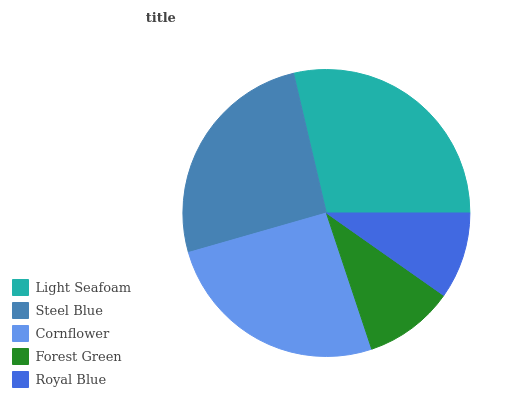Is Royal Blue the minimum?
Answer yes or no. Yes. Is Light Seafoam the maximum?
Answer yes or no. Yes. Is Steel Blue the minimum?
Answer yes or no. No. Is Steel Blue the maximum?
Answer yes or no. No. Is Light Seafoam greater than Steel Blue?
Answer yes or no. Yes. Is Steel Blue less than Light Seafoam?
Answer yes or no. Yes. Is Steel Blue greater than Light Seafoam?
Answer yes or no. No. Is Light Seafoam less than Steel Blue?
Answer yes or no. No. Is Cornflower the high median?
Answer yes or no. Yes. Is Cornflower the low median?
Answer yes or no. Yes. Is Steel Blue the high median?
Answer yes or no. No. Is Steel Blue the low median?
Answer yes or no. No. 